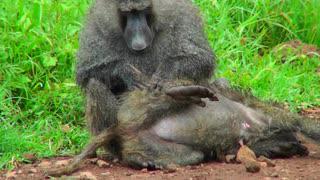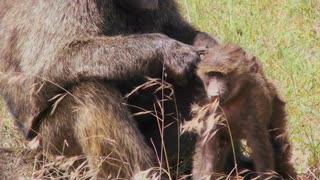The first image is the image on the left, the second image is the image on the right. Considering the images on both sides, is "There are exactly four apes." valid? Answer yes or no. Yes. The first image is the image on the left, the second image is the image on the right. Considering the images on both sides, is "a baboon is grooming another baboon's leg while it lays down" valid? Answer yes or no. Yes. 